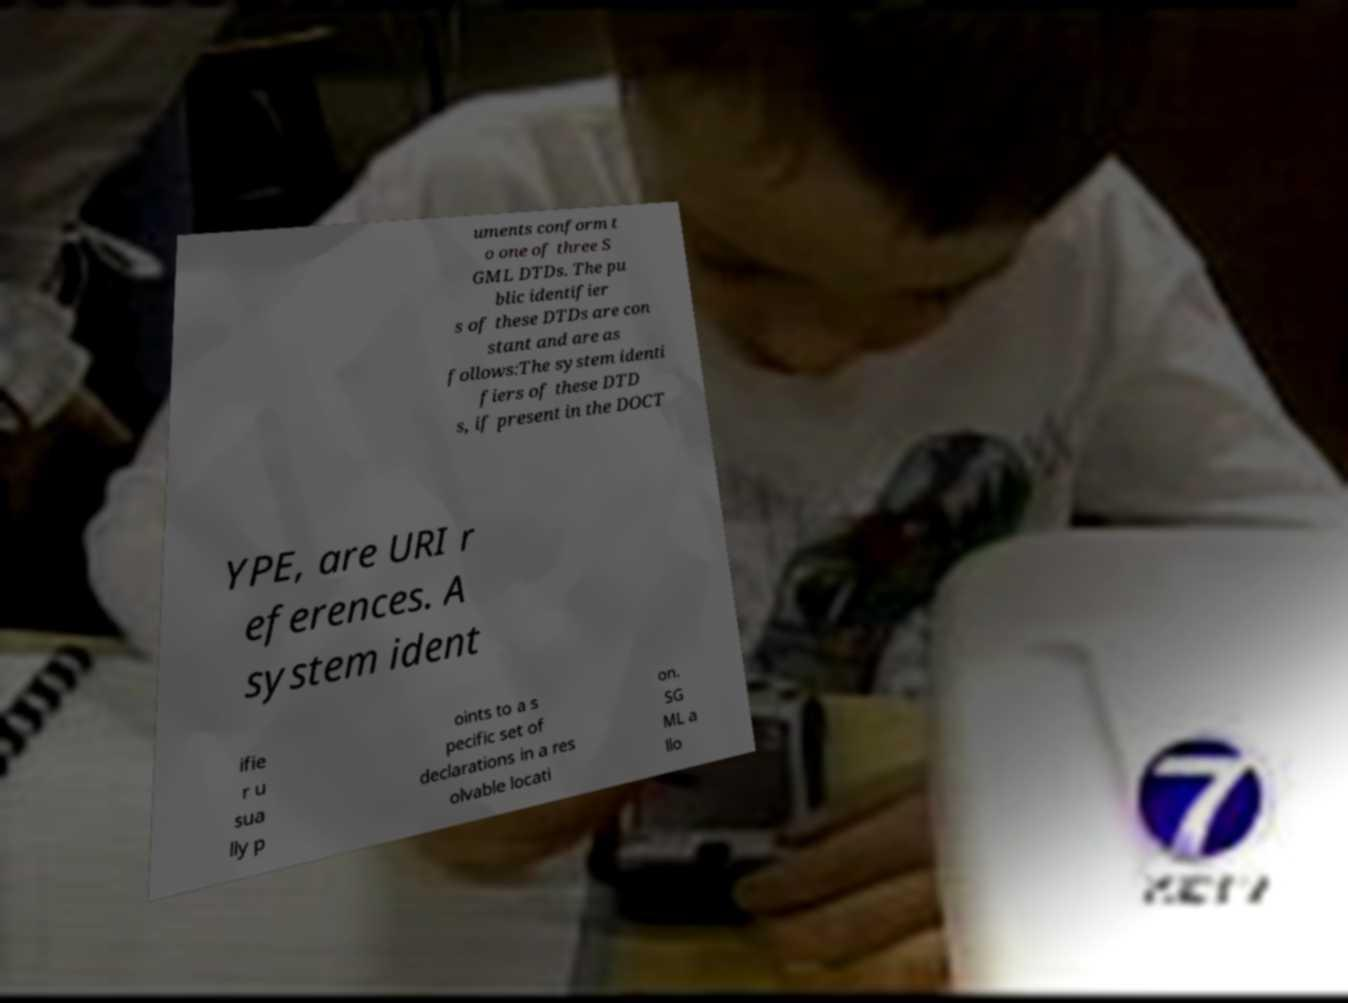Can you accurately transcribe the text from the provided image for me? uments conform t o one of three S GML DTDs. The pu blic identifier s of these DTDs are con stant and are as follows:The system identi fiers of these DTD s, if present in the DOCT YPE, are URI r eferences. A system ident ifie r u sua lly p oints to a s pecific set of declarations in a res olvable locati on. SG ML a llo 